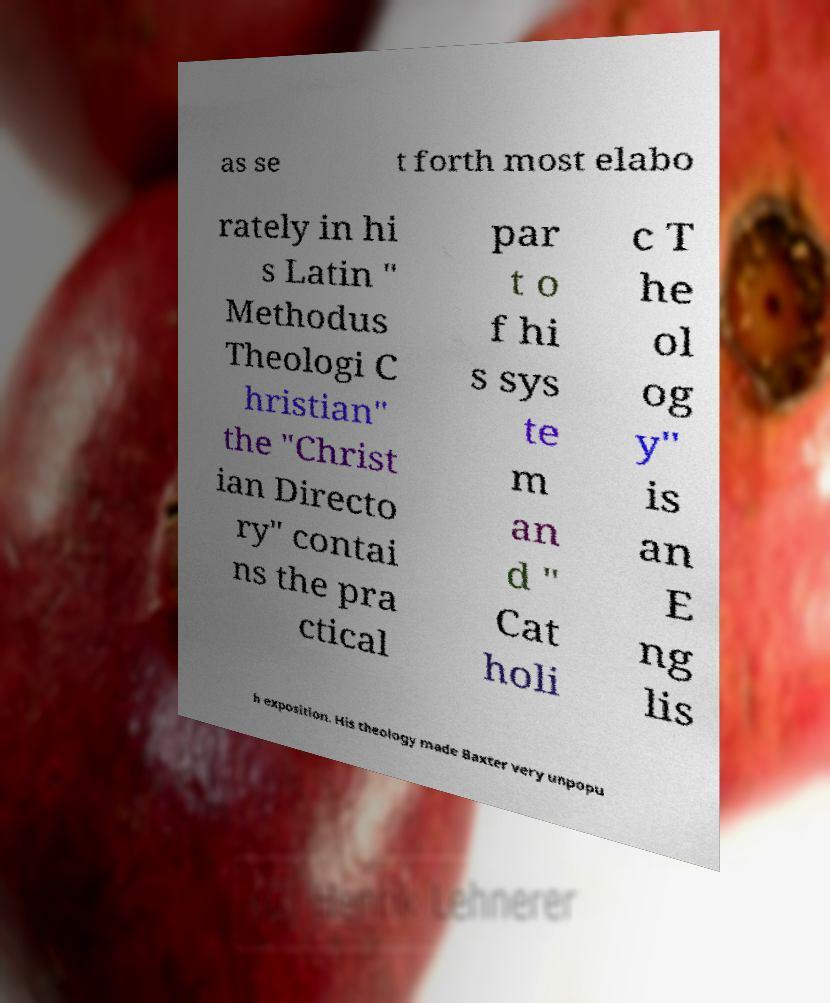For documentation purposes, I need the text within this image transcribed. Could you provide that? as se t forth most elabo rately in hi s Latin " Methodus Theologi C hristian" the "Christ ian Directo ry" contai ns the pra ctical par t o f hi s sys te m an d " Cat holi c T he ol og y" is an E ng lis h exposition. His theology made Baxter very unpopu 